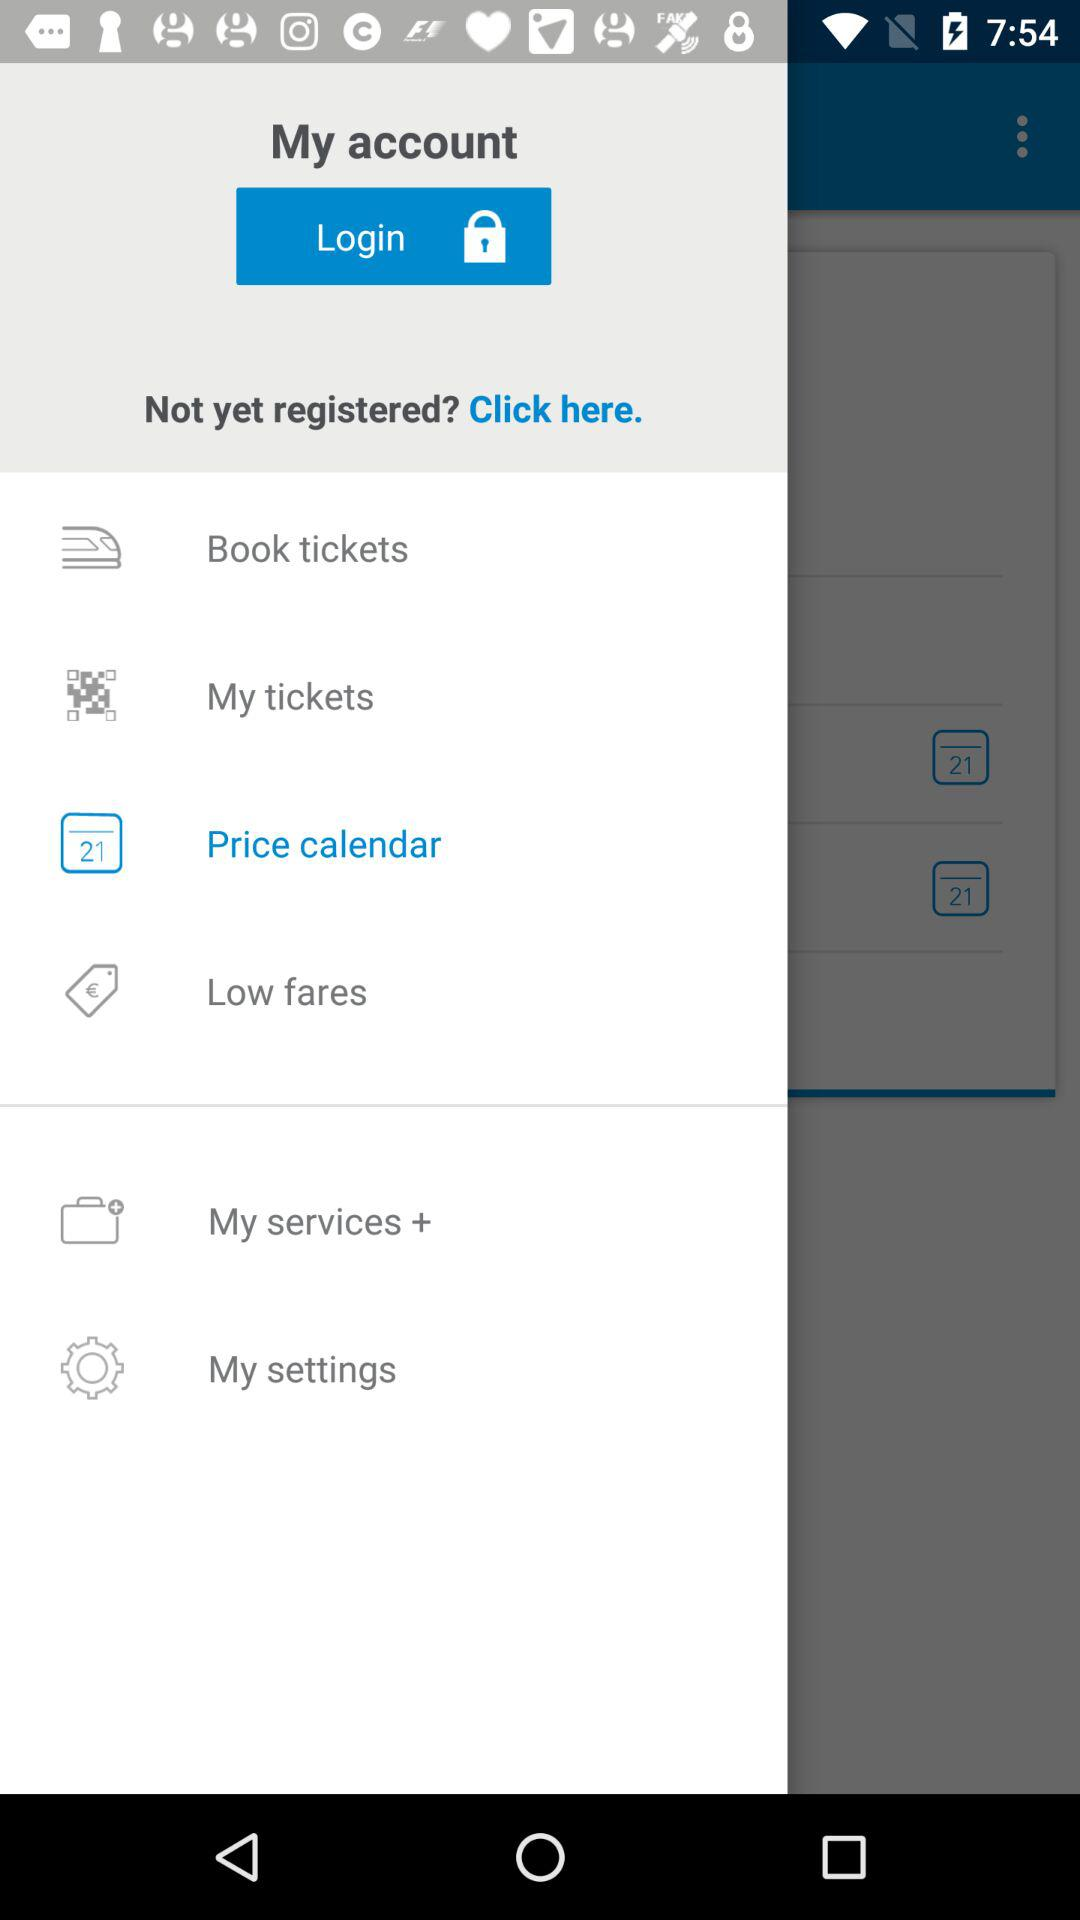Which item has been selected in the menu? The item "Price calendar" has been selected in the menu. 